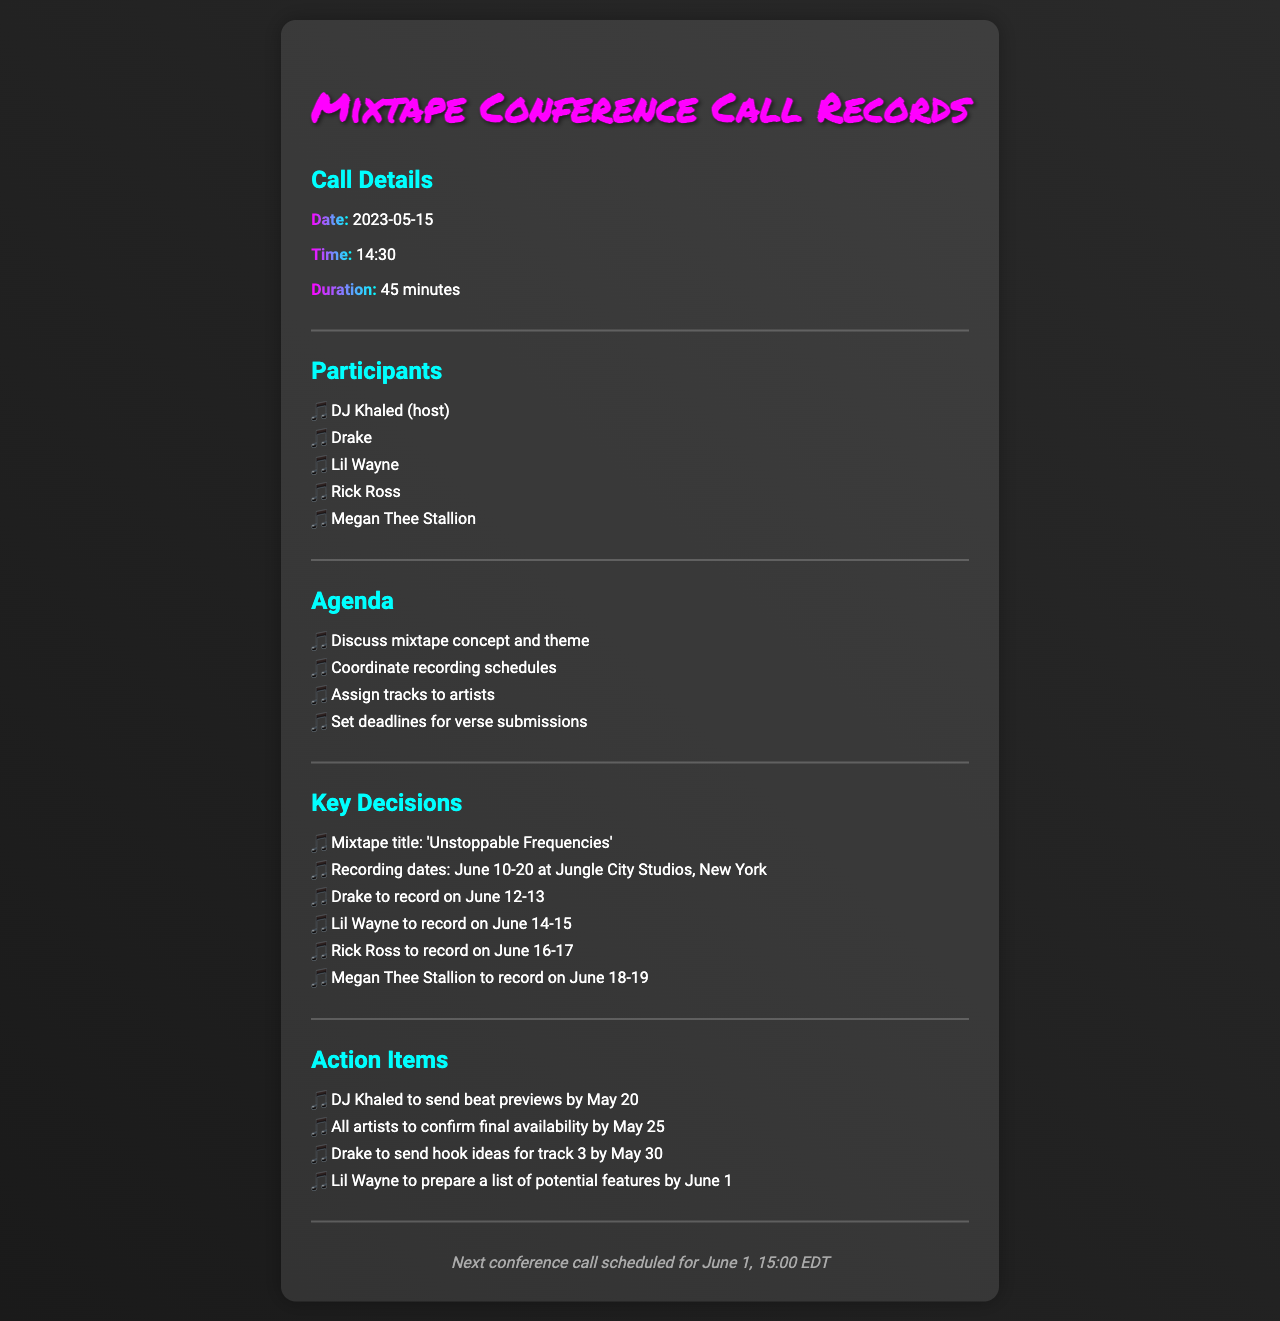what is the date of the conference call? The date of the conference call is provided in the call details section of the document.
Answer: 2023-05-15 who was the host of the call? The host is listed in the participants section of the document.
Answer: DJ Khaled what is the title of the mixtape? The title is mentioned in the key decisions section under mixtape title.
Answer: 'Unstoppable Frequencies' how many minutes did the call last? The duration of the call is specified in the call details section.
Answer: 45 minutes what are the recording dates for the mixtape? The recording dates are noted in the key decisions section.
Answer: June 10-20 who is recording on June 16-17? The recording schedule provided in the key decisions section specifies the artists and their dates.
Answer: Rick Ross when is the next conference call scheduled? This information is provided in the footer of the document.
Answer: June 1, 15:00 EDT how many action items are listed? The action items section contains a list that can be counted.
Answer: 4 what is the deadline for Drake to send hook ideas for track 3? This deadline is specified in the action items section of the document.
Answer: May 30 